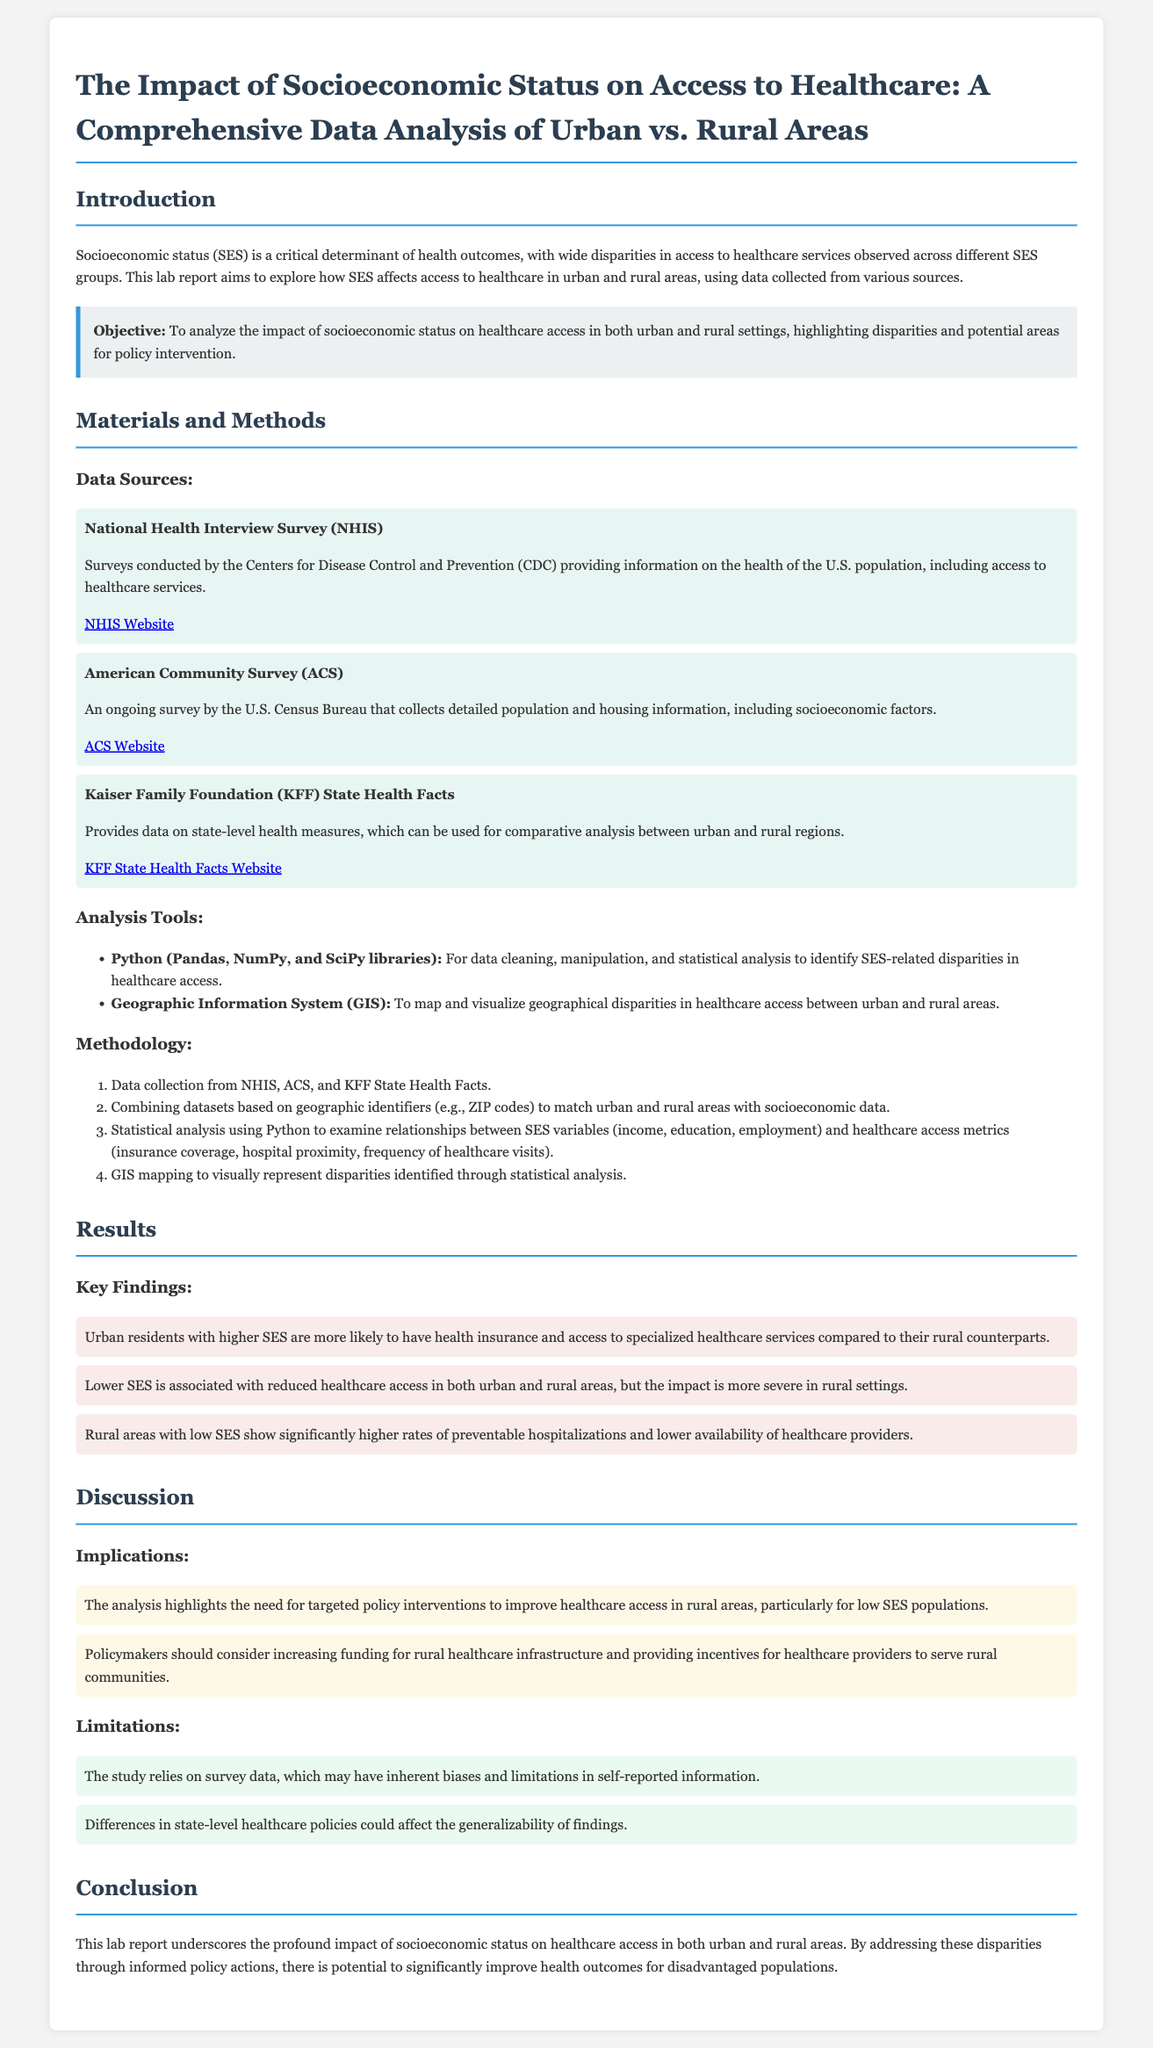What is the main objective of the report? The report aims to analyze the impact of socioeconomic status on healthcare access in both urban and rural settings, highlighting disparities and potential areas for policy intervention.
Answer: To analyze the impact of socioeconomic status on healthcare access What survey provides information on the health of the U.S. population? The National Health Interview Survey provides information on the health of the U.S. population, including access to healthcare services.
Answer: National Health Interview Survey Which socioeconomic factors were analyzed? The analysis focused on income, education, and employment as socioeconomic factors affecting healthcare access.
Answer: Income, education, employment What is one implication of the findings? The analysis highlights the need for targeted policy interventions to improve healthcare access in rural areas, particularly for low SES populations.
Answer: Targeted policy interventions How many data sources were mentioned in the report? Three data sources were discussed, including NHIS, ACS, and KFF State Health Facts.
Answer: Three 